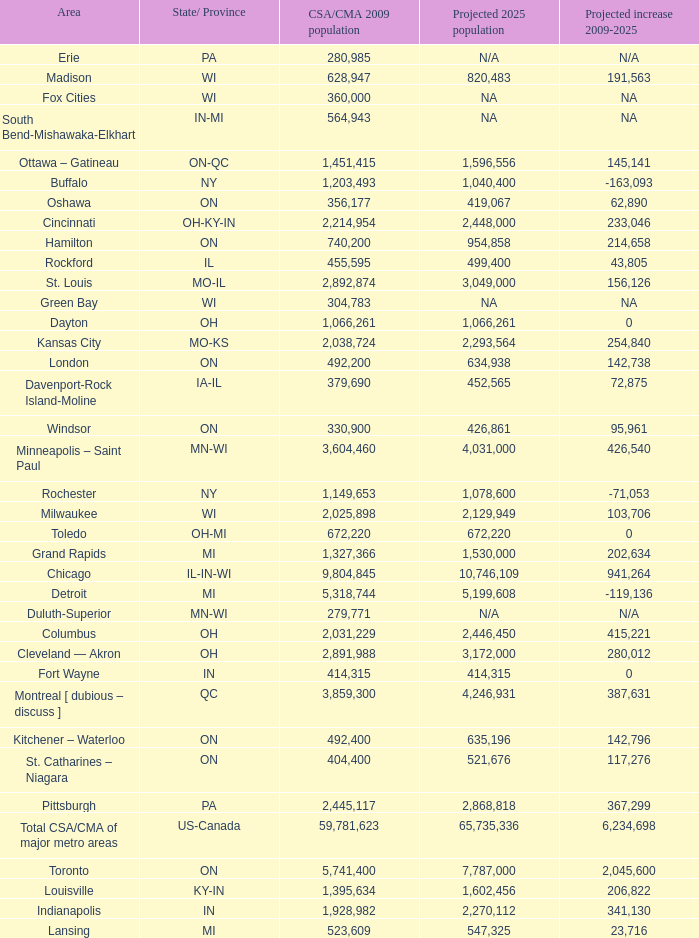What's the CSA/CMA Population in IA-IL? 379690.0. 